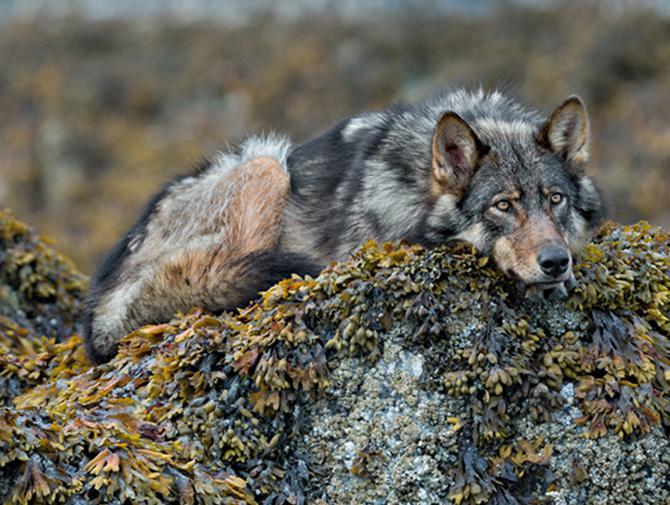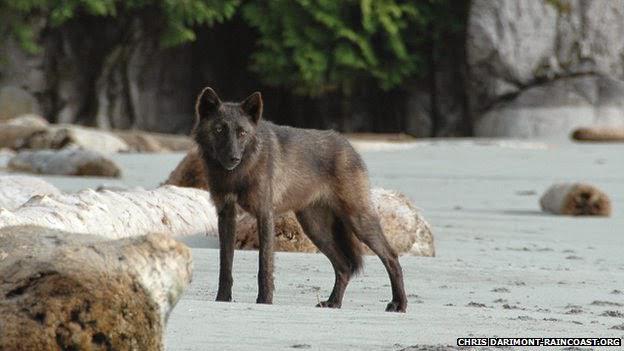The first image is the image on the left, the second image is the image on the right. For the images shown, is this caption "A wolf is lying down in one picture and standing in the other." true? Answer yes or no. Yes. The first image is the image on the left, the second image is the image on the right. Analyze the images presented: Is the assertion "There is a total of 1 adult wolf laying down." valid? Answer yes or no. Yes. 